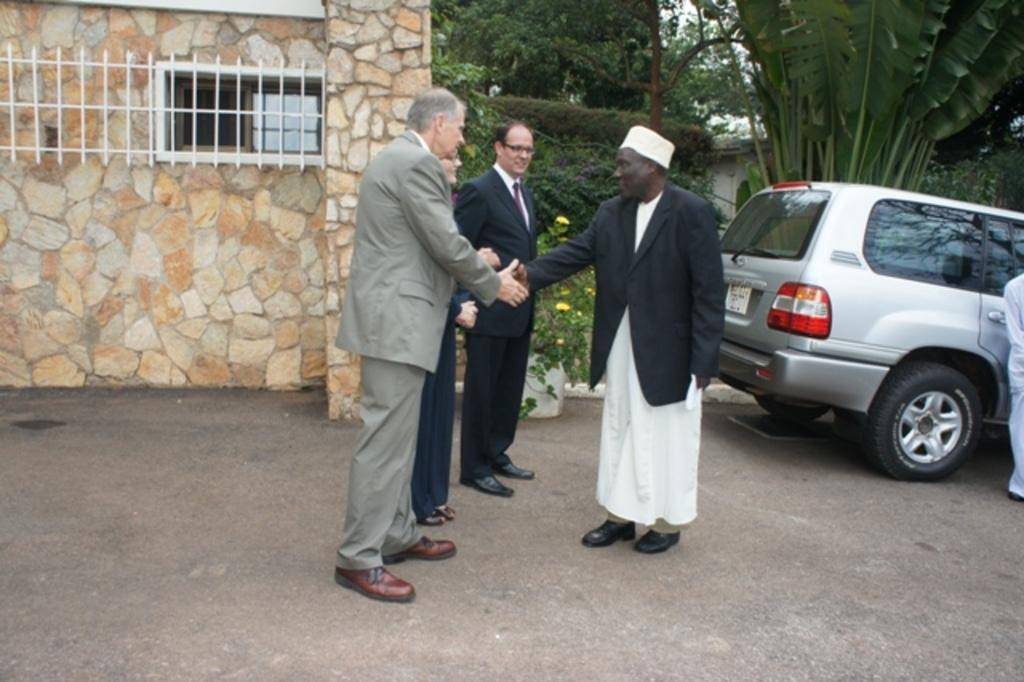What are the people in the image doing? The people in the image are shaking their hands. What can be seen in the background of the image? There is a car, plants, trees, and a building in the background of the image. How many thumbs does the person in the image have? There is no specific person mentioned in the image, and the number of thumbs cannot be determined from the image. What type of bushes are present in the image? There is no mention of bushes in the image; the background features a car, plants, trees, and a building. 